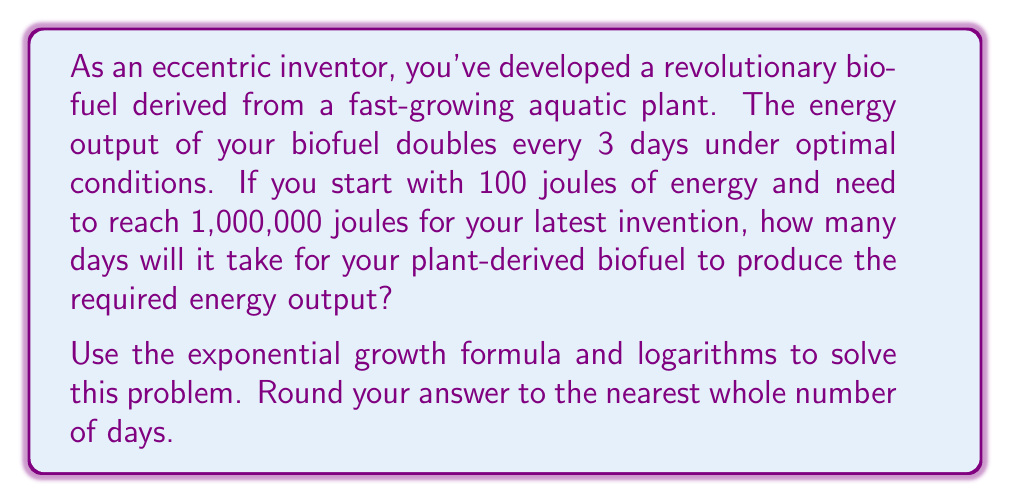Could you help me with this problem? Let's approach this step-by-step using the exponential growth formula and logarithms:

1) The exponential growth formula is:
   $$ A = P(1 + r)^t $$
   Where:
   $A$ is the final amount
   $P$ is the initial amount
   $r$ is the growth rate
   $t$ is the time

2) In this case, the growth doubles every 3 days, so we can rewrite the formula as:
   $$ A = P(2)^{t/3} $$

3) We know:
   $P = 100$ joules (initial energy)
   $A = 1,000,000$ joules (target energy)

4) Let's substitute these values:
   $$ 1,000,000 = 100(2)^{t/3} $$

5) Divide both sides by 100:
   $$ 10,000 = 2^{t/3} $$

6) Now, let's apply logarithms (base 2) to both sides:
   $$ \log_2(10,000) = \log_2(2^{t/3}) $$

7) The right side simplifies due to the logarithm rule $\log_a(a^x) = x$:
   $$ \log_2(10,000) = t/3 $$

8) Calculate $\log_2(10,000)$:
   $$ \log_2(10,000) = 13.2877 $$

9) Now we can solve for $t$:
   $$ t = 3 * 13.2877 = 39.8631 \text{ days} $$

10) Rounding to the nearest whole number:
    $$ t \approx 40 \text{ days} $$
Answer: It will take approximately 40 days for the plant-derived biofuel to produce 1,000,000 joules of energy. 